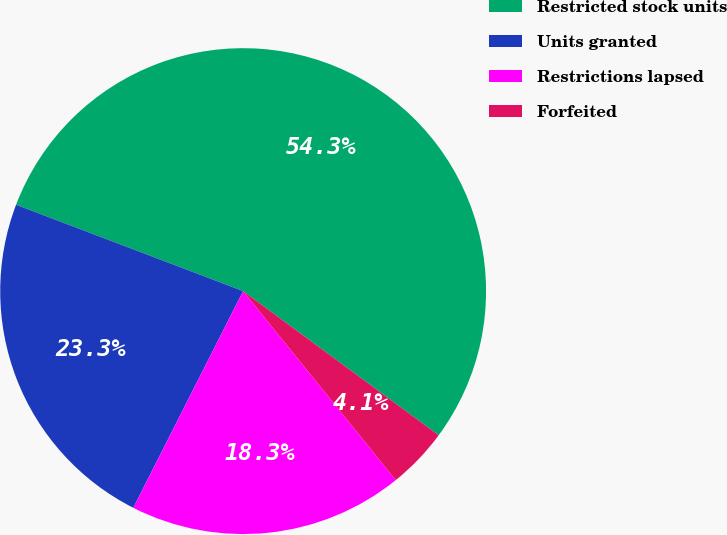Convert chart. <chart><loc_0><loc_0><loc_500><loc_500><pie_chart><fcel>Restricted stock units<fcel>Units granted<fcel>Restrictions lapsed<fcel>Forfeited<nl><fcel>54.33%<fcel>23.32%<fcel>18.28%<fcel>4.08%<nl></chart> 